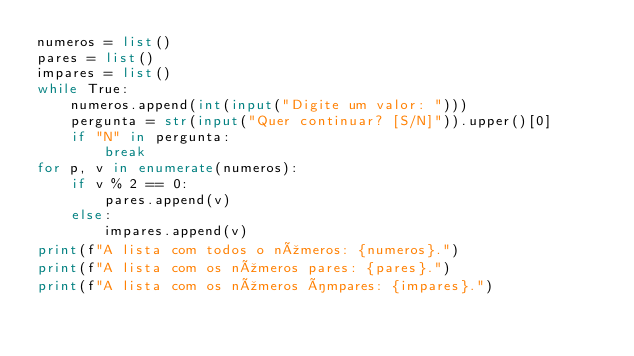<code> <loc_0><loc_0><loc_500><loc_500><_Python_>numeros = list()
pares = list()
impares = list()
while True:
    numeros.append(int(input("Digite um valor: ")))
    pergunta = str(input("Quer continuar? [S/N]")).upper()[0]
    if "N" in pergunta:
        break
for p, v in enumerate(numeros):
    if v % 2 == 0:
        pares.append(v)
    else:
        impares.append(v)
print(f"A lista com todos o números: {numeros}.")
print(f"A lista com os números pares: {pares}.")
print(f"A lista com os números ímpares: {impares}.")
</code> 